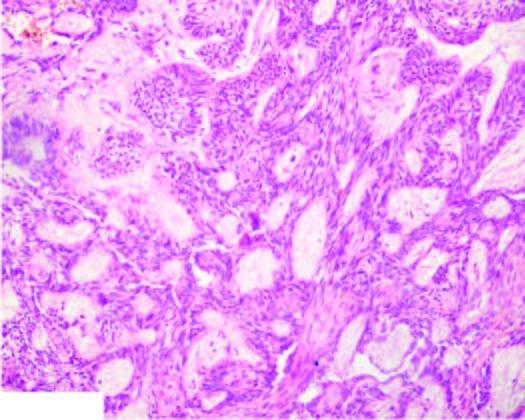what show irregular plexiform masses and network of strands of epithelial cells?
Answer the question using a single word or phrase. Plexiform areas 